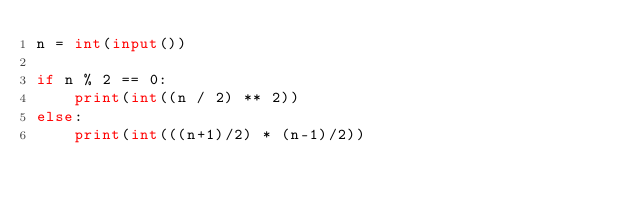Convert code to text. <code><loc_0><loc_0><loc_500><loc_500><_Python_>n = int(input())

if n % 2 == 0:
    print(int((n / 2) ** 2))
else:
    print(int(((n+1)/2) * (n-1)/2))</code> 